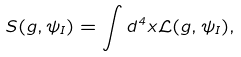Convert formula to latex. <formula><loc_0><loc_0><loc_500><loc_500>S ( g , \psi _ { I } ) = \int d ^ { 4 } x \mathcal { L } ( g , \psi _ { I } ) ,</formula> 